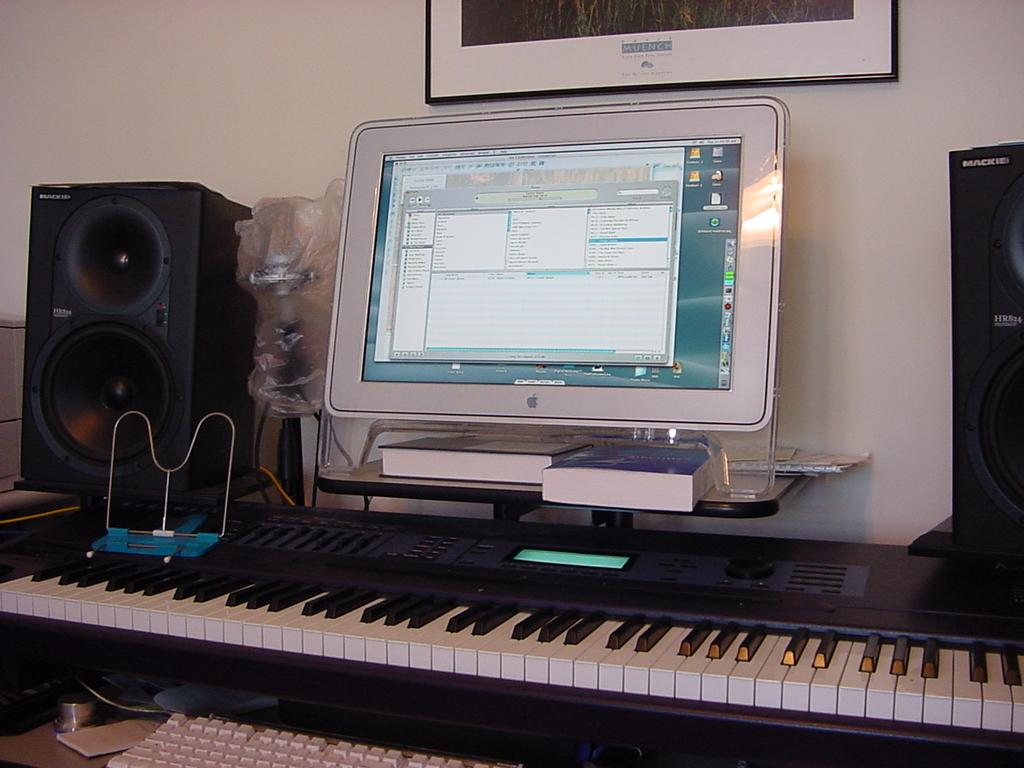What electronic device is visible in the image? There is a monitor in the image. What musical instrument can be seen in the image? There is a piano in the image. What input device is present in the image? There is a keyboard in the image. What is used for amplifying sound in the image? There are speakers on the table in the image. What is hanging on the wall in the background of the image? There is a photo frame attached to the wall in the background of the image. How many beds are visible in the image? There are no beds present in the image. What type of letter can be seen on the keyboard in the image? There is no letter visible on the keyboard in the image. 